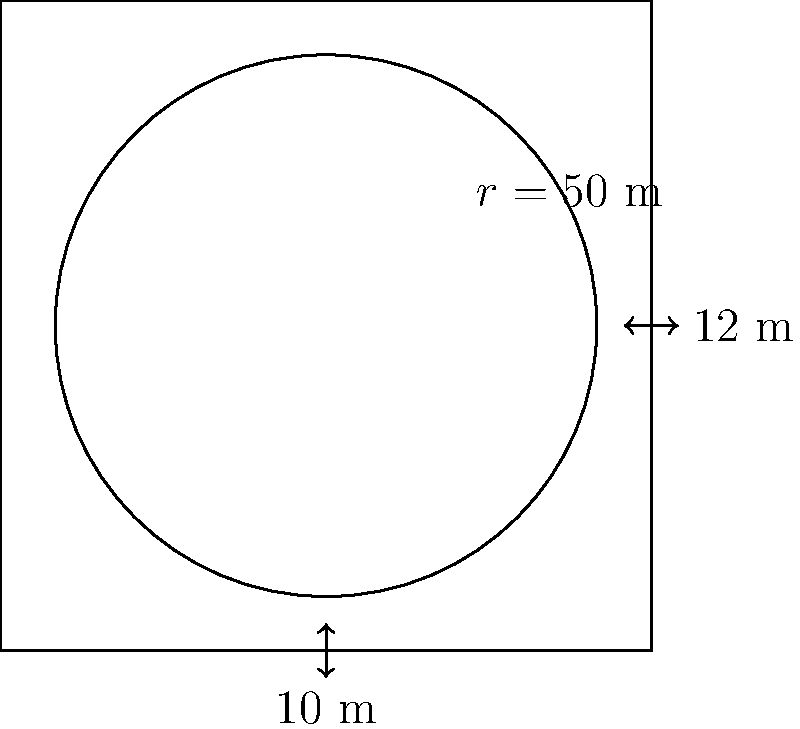As a logistics coordinator, you're designing a new circular parking lot for your fleet. The lot has a radius of 50 meters and includes two rectangular entrance ways, each 10 meters wide and 12 meters long, as shown in the diagram. What is the total perimeter of this parking lot? Let's approach this step-by-step:

1) First, calculate the circumference of the circular part:
   $C = 2\pi r = 2\pi \cdot 50 = 100\pi$ meters

2) Now, we need to subtract the arcs where the entrances are:
   Each entrance is 10 meters wide.
   Arc length = $\frac{10}{50} \cdot \frac{1}{2}\pi r = \frac{1}{5}\pi r = \frac{1}{5}\pi \cdot 50 = 10\pi$ meters
   For two entrances: $2 \cdot 10\pi = 20\pi$ meters

3) Subtract this from the full circumference:
   Remaining circular perimeter = $100\pi - 20\pi = 80\pi$ meters

4) Now add the straight edges of the entrances:
   For each entrance: $10 + 12 + 12 = 34$ meters
   For both entrances: $2 \cdot 34 = 68$ meters

5) Total perimeter:
   $80\pi + 68$ meters

6) If we need a numerical value, we can calculate:
   $80\pi + 68 \approx 319.27$ meters
Answer: $80\pi + 68$ meters (or approximately 319.27 meters) 